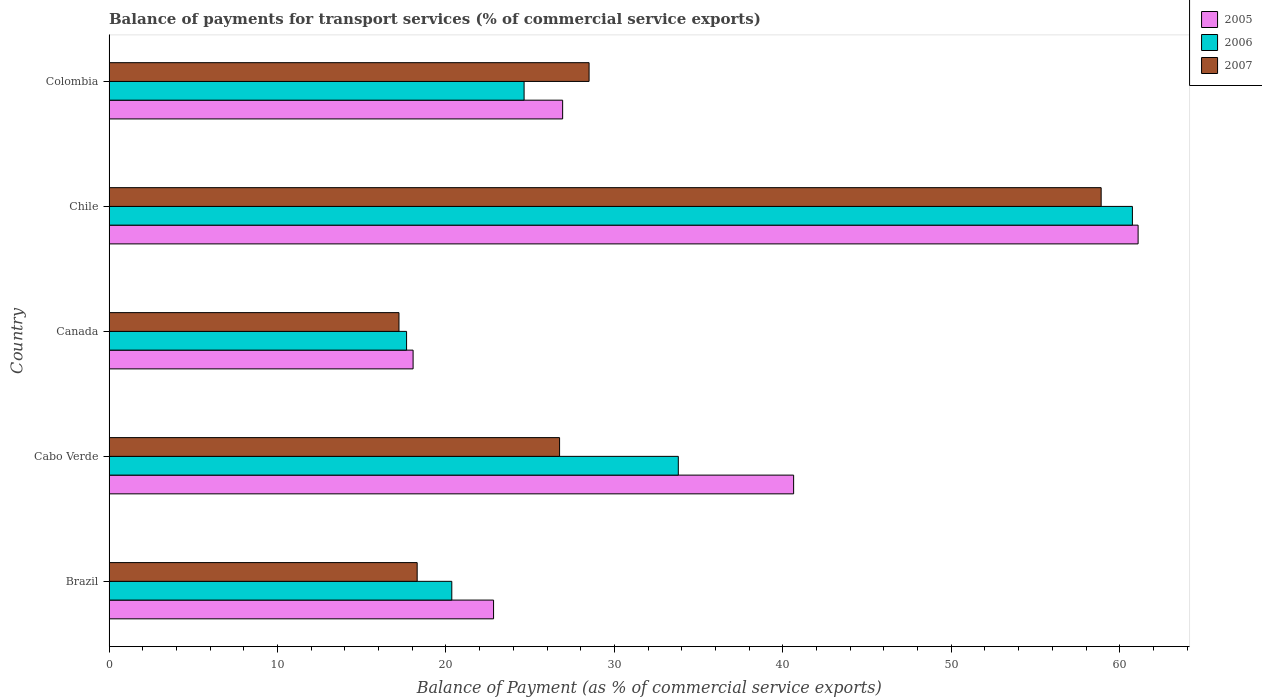How many different coloured bars are there?
Keep it short and to the point. 3. How many groups of bars are there?
Give a very brief answer. 5. Are the number of bars on each tick of the Y-axis equal?
Make the answer very short. Yes. How many bars are there on the 5th tick from the top?
Make the answer very short. 3. How many bars are there on the 1st tick from the bottom?
Offer a very short reply. 3. What is the label of the 3rd group of bars from the top?
Your answer should be very brief. Canada. In how many cases, is the number of bars for a given country not equal to the number of legend labels?
Offer a very short reply. 0. What is the balance of payments for transport services in 2005 in Canada?
Provide a short and direct response. 18.05. Across all countries, what is the maximum balance of payments for transport services in 2005?
Offer a very short reply. 61.09. Across all countries, what is the minimum balance of payments for transport services in 2006?
Your answer should be very brief. 17.66. In which country was the balance of payments for transport services in 2005 minimum?
Provide a short and direct response. Canada. What is the total balance of payments for transport services in 2007 in the graph?
Give a very brief answer. 149.64. What is the difference between the balance of payments for transport services in 2007 in Cabo Verde and that in Chile?
Offer a very short reply. -32.15. What is the difference between the balance of payments for transport services in 2007 in Brazil and the balance of payments for transport services in 2006 in Colombia?
Provide a short and direct response. -6.35. What is the average balance of payments for transport services in 2007 per country?
Ensure brevity in your answer.  29.93. What is the difference between the balance of payments for transport services in 2005 and balance of payments for transport services in 2006 in Colombia?
Your response must be concise. 2.29. What is the ratio of the balance of payments for transport services in 2006 in Chile to that in Colombia?
Your answer should be compact. 2.47. Is the balance of payments for transport services in 2005 in Canada less than that in Colombia?
Make the answer very short. Yes. Is the difference between the balance of payments for transport services in 2005 in Brazil and Chile greater than the difference between the balance of payments for transport services in 2006 in Brazil and Chile?
Your response must be concise. Yes. What is the difference between the highest and the second highest balance of payments for transport services in 2007?
Ensure brevity in your answer.  30.4. What is the difference between the highest and the lowest balance of payments for transport services in 2007?
Keep it short and to the point. 41.69. In how many countries, is the balance of payments for transport services in 2005 greater than the average balance of payments for transport services in 2005 taken over all countries?
Offer a terse response. 2. Is the sum of the balance of payments for transport services in 2005 in Canada and Colombia greater than the maximum balance of payments for transport services in 2007 across all countries?
Provide a short and direct response. No. What does the 3rd bar from the top in Colombia represents?
Ensure brevity in your answer.  2005. What does the 2nd bar from the bottom in Chile represents?
Ensure brevity in your answer.  2006. Is it the case that in every country, the sum of the balance of payments for transport services in 2006 and balance of payments for transport services in 2005 is greater than the balance of payments for transport services in 2007?
Provide a succinct answer. Yes. How many bars are there?
Provide a short and direct response. 15. Are all the bars in the graph horizontal?
Provide a short and direct response. Yes. How many countries are there in the graph?
Ensure brevity in your answer.  5. What is the difference between two consecutive major ticks on the X-axis?
Provide a short and direct response. 10. Are the values on the major ticks of X-axis written in scientific E-notation?
Offer a terse response. No. Does the graph contain any zero values?
Offer a very short reply. No. Does the graph contain grids?
Provide a succinct answer. No. Where does the legend appear in the graph?
Offer a terse response. Top right. How many legend labels are there?
Provide a short and direct response. 3. What is the title of the graph?
Your answer should be compact. Balance of payments for transport services (% of commercial service exports). Does "1960" appear as one of the legend labels in the graph?
Offer a terse response. No. What is the label or title of the X-axis?
Provide a short and direct response. Balance of Payment (as % of commercial service exports). What is the Balance of Payment (as % of commercial service exports) of 2005 in Brazil?
Your answer should be very brief. 22.83. What is the Balance of Payment (as % of commercial service exports) in 2006 in Brazil?
Give a very brief answer. 20.35. What is the Balance of Payment (as % of commercial service exports) in 2007 in Brazil?
Provide a short and direct response. 18.29. What is the Balance of Payment (as % of commercial service exports) of 2005 in Cabo Verde?
Offer a very short reply. 40.64. What is the Balance of Payment (as % of commercial service exports) in 2006 in Cabo Verde?
Offer a very short reply. 33.79. What is the Balance of Payment (as % of commercial service exports) in 2007 in Cabo Verde?
Make the answer very short. 26.75. What is the Balance of Payment (as % of commercial service exports) in 2005 in Canada?
Give a very brief answer. 18.05. What is the Balance of Payment (as % of commercial service exports) in 2006 in Canada?
Ensure brevity in your answer.  17.66. What is the Balance of Payment (as % of commercial service exports) in 2007 in Canada?
Make the answer very short. 17.21. What is the Balance of Payment (as % of commercial service exports) in 2005 in Chile?
Offer a terse response. 61.09. What is the Balance of Payment (as % of commercial service exports) in 2006 in Chile?
Provide a short and direct response. 60.75. What is the Balance of Payment (as % of commercial service exports) of 2007 in Chile?
Your response must be concise. 58.9. What is the Balance of Payment (as % of commercial service exports) in 2005 in Colombia?
Your response must be concise. 26.93. What is the Balance of Payment (as % of commercial service exports) in 2006 in Colombia?
Your answer should be compact. 24.64. What is the Balance of Payment (as % of commercial service exports) in 2007 in Colombia?
Your response must be concise. 28.5. Across all countries, what is the maximum Balance of Payment (as % of commercial service exports) in 2005?
Your answer should be very brief. 61.09. Across all countries, what is the maximum Balance of Payment (as % of commercial service exports) in 2006?
Make the answer very short. 60.75. Across all countries, what is the maximum Balance of Payment (as % of commercial service exports) of 2007?
Make the answer very short. 58.9. Across all countries, what is the minimum Balance of Payment (as % of commercial service exports) of 2005?
Give a very brief answer. 18.05. Across all countries, what is the minimum Balance of Payment (as % of commercial service exports) in 2006?
Provide a succinct answer. 17.66. Across all countries, what is the minimum Balance of Payment (as % of commercial service exports) of 2007?
Keep it short and to the point. 17.21. What is the total Balance of Payment (as % of commercial service exports) in 2005 in the graph?
Offer a very short reply. 169.53. What is the total Balance of Payment (as % of commercial service exports) of 2006 in the graph?
Ensure brevity in your answer.  157.2. What is the total Balance of Payment (as % of commercial service exports) in 2007 in the graph?
Provide a succinct answer. 149.64. What is the difference between the Balance of Payment (as % of commercial service exports) in 2005 in Brazil and that in Cabo Verde?
Ensure brevity in your answer.  -17.81. What is the difference between the Balance of Payment (as % of commercial service exports) in 2006 in Brazil and that in Cabo Verde?
Your response must be concise. -13.45. What is the difference between the Balance of Payment (as % of commercial service exports) of 2007 in Brazil and that in Cabo Verde?
Provide a short and direct response. -8.45. What is the difference between the Balance of Payment (as % of commercial service exports) of 2005 in Brazil and that in Canada?
Ensure brevity in your answer.  4.78. What is the difference between the Balance of Payment (as % of commercial service exports) in 2006 in Brazil and that in Canada?
Offer a terse response. 2.68. What is the difference between the Balance of Payment (as % of commercial service exports) of 2007 in Brazil and that in Canada?
Keep it short and to the point. 1.08. What is the difference between the Balance of Payment (as % of commercial service exports) of 2005 in Brazil and that in Chile?
Provide a succinct answer. -38.26. What is the difference between the Balance of Payment (as % of commercial service exports) in 2006 in Brazil and that in Chile?
Keep it short and to the point. -40.4. What is the difference between the Balance of Payment (as % of commercial service exports) in 2007 in Brazil and that in Chile?
Provide a succinct answer. -40.61. What is the difference between the Balance of Payment (as % of commercial service exports) in 2005 in Brazil and that in Colombia?
Your response must be concise. -4.1. What is the difference between the Balance of Payment (as % of commercial service exports) of 2006 in Brazil and that in Colombia?
Give a very brief answer. -4.29. What is the difference between the Balance of Payment (as % of commercial service exports) of 2007 in Brazil and that in Colombia?
Ensure brevity in your answer.  -10.21. What is the difference between the Balance of Payment (as % of commercial service exports) of 2005 in Cabo Verde and that in Canada?
Keep it short and to the point. 22.59. What is the difference between the Balance of Payment (as % of commercial service exports) in 2006 in Cabo Verde and that in Canada?
Offer a terse response. 16.13. What is the difference between the Balance of Payment (as % of commercial service exports) of 2007 in Cabo Verde and that in Canada?
Keep it short and to the point. 9.53. What is the difference between the Balance of Payment (as % of commercial service exports) in 2005 in Cabo Verde and that in Chile?
Ensure brevity in your answer.  -20.45. What is the difference between the Balance of Payment (as % of commercial service exports) of 2006 in Cabo Verde and that in Chile?
Your answer should be very brief. -26.96. What is the difference between the Balance of Payment (as % of commercial service exports) in 2007 in Cabo Verde and that in Chile?
Keep it short and to the point. -32.15. What is the difference between the Balance of Payment (as % of commercial service exports) of 2005 in Cabo Verde and that in Colombia?
Offer a terse response. 13.71. What is the difference between the Balance of Payment (as % of commercial service exports) in 2006 in Cabo Verde and that in Colombia?
Provide a succinct answer. 9.15. What is the difference between the Balance of Payment (as % of commercial service exports) of 2007 in Cabo Verde and that in Colombia?
Offer a terse response. -1.75. What is the difference between the Balance of Payment (as % of commercial service exports) in 2005 in Canada and that in Chile?
Ensure brevity in your answer.  -43.04. What is the difference between the Balance of Payment (as % of commercial service exports) in 2006 in Canada and that in Chile?
Provide a short and direct response. -43.09. What is the difference between the Balance of Payment (as % of commercial service exports) of 2007 in Canada and that in Chile?
Keep it short and to the point. -41.69. What is the difference between the Balance of Payment (as % of commercial service exports) in 2005 in Canada and that in Colombia?
Your response must be concise. -8.88. What is the difference between the Balance of Payment (as % of commercial service exports) of 2006 in Canada and that in Colombia?
Offer a terse response. -6.98. What is the difference between the Balance of Payment (as % of commercial service exports) of 2007 in Canada and that in Colombia?
Provide a succinct answer. -11.29. What is the difference between the Balance of Payment (as % of commercial service exports) of 2005 in Chile and that in Colombia?
Offer a very short reply. 34.16. What is the difference between the Balance of Payment (as % of commercial service exports) in 2006 in Chile and that in Colombia?
Your answer should be very brief. 36.11. What is the difference between the Balance of Payment (as % of commercial service exports) of 2007 in Chile and that in Colombia?
Your response must be concise. 30.4. What is the difference between the Balance of Payment (as % of commercial service exports) of 2005 in Brazil and the Balance of Payment (as % of commercial service exports) of 2006 in Cabo Verde?
Offer a very short reply. -10.97. What is the difference between the Balance of Payment (as % of commercial service exports) of 2005 in Brazil and the Balance of Payment (as % of commercial service exports) of 2007 in Cabo Verde?
Ensure brevity in your answer.  -3.92. What is the difference between the Balance of Payment (as % of commercial service exports) in 2006 in Brazil and the Balance of Payment (as % of commercial service exports) in 2007 in Cabo Verde?
Offer a terse response. -6.4. What is the difference between the Balance of Payment (as % of commercial service exports) in 2005 in Brazil and the Balance of Payment (as % of commercial service exports) in 2006 in Canada?
Your answer should be compact. 5.16. What is the difference between the Balance of Payment (as % of commercial service exports) in 2005 in Brazil and the Balance of Payment (as % of commercial service exports) in 2007 in Canada?
Your answer should be very brief. 5.62. What is the difference between the Balance of Payment (as % of commercial service exports) in 2006 in Brazil and the Balance of Payment (as % of commercial service exports) in 2007 in Canada?
Make the answer very short. 3.14. What is the difference between the Balance of Payment (as % of commercial service exports) of 2005 in Brazil and the Balance of Payment (as % of commercial service exports) of 2006 in Chile?
Give a very brief answer. -37.93. What is the difference between the Balance of Payment (as % of commercial service exports) in 2005 in Brazil and the Balance of Payment (as % of commercial service exports) in 2007 in Chile?
Make the answer very short. -36.07. What is the difference between the Balance of Payment (as % of commercial service exports) of 2006 in Brazil and the Balance of Payment (as % of commercial service exports) of 2007 in Chile?
Give a very brief answer. -38.55. What is the difference between the Balance of Payment (as % of commercial service exports) in 2005 in Brazil and the Balance of Payment (as % of commercial service exports) in 2006 in Colombia?
Your answer should be compact. -1.81. What is the difference between the Balance of Payment (as % of commercial service exports) of 2005 in Brazil and the Balance of Payment (as % of commercial service exports) of 2007 in Colombia?
Your answer should be compact. -5.67. What is the difference between the Balance of Payment (as % of commercial service exports) in 2006 in Brazil and the Balance of Payment (as % of commercial service exports) in 2007 in Colombia?
Your answer should be compact. -8.15. What is the difference between the Balance of Payment (as % of commercial service exports) in 2005 in Cabo Verde and the Balance of Payment (as % of commercial service exports) in 2006 in Canada?
Make the answer very short. 22.98. What is the difference between the Balance of Payment (as % of commercial service exports) of 2005 in Cabo Verde and the Balance of Payment (as % of commercial service exports) of 2007 in Canada?
Offer a terse response. 23.43. What is the difference between the Balance of Payment (as % of commercial service exports) of 2006 in Cabo Verde and the Balance of Payment (as % of commercial service exports) of 2007 in Canada?
Make the answer very short. 16.58. What is the difference between the Balance of Payment (as % of commercial service exports) of 2005 in Cabo Verde and the Balance of Payment (as % of commercial service exports) of 2006 in Chile?
Your answer should be compact. -20.11. What is the difference between the Balance of Payment (as % of commercial service exports) of 2005 in Cabo Verde and the Balance of Payment (as % of commercial service exports) of 2007 in Chile?
Keep it short and to the point. -18.26. What is the difference between the Balance of Payment (as % of commercial service exports) of 2006 in Cabo Verde and the Balance of Payment (as % of commercial service exports) of 2007 in Chile?
Your answer should be compact. -25.1. What is the difference between the Balance of Payment (as % of commercial service exports) in 2005 in Cabo Verde and the Balance of Payment (as % of commercial service exports) in 2006 in Colombia?
Keep it short and to the point. 16. What is the difference between the Balance of Payment (as % of commercial service exports) in 2005 in Cabo Verde and the Balance of Payment (as % of commercial service exports) in 2007 in Colombia?
Your response must be concise. 12.14. What is the difference between the Balance of Payment (as % of commercial service exports) in 2006 in Cabo Verde and the Balance of Payment (as % of commercial service exports) in 2007 in Colombia?
Keep it short and to the point. 5.3. What is the difference between the Balance of Payment (as % of commercial service exports) of 2005 in Canada and the Balance of Payment (as % of commercial service exports) of 2006 in Chile?
Offer a terse response. -42.7. What is the difference between the Balance of Payment (as % of commercial service exports) of 2005 in Canada and the Balance of Payment (as % of commercial service exports) of 2007 in Chile?
Keep it short and to the point. -40.85. What is the difference between the Balance of Payment (as % of commercial service exports) of 2006 in Canada and the Balance of Payment (as % of commercial service exports) of 2007 in Chile?
Offer a very short reply. -41.23. What is the difference between the Balance of Payment (as % of commercial service exports) in 2005 in Canada and the Balance of Payment (as % of commercial service exports) in 2006 in Colombia?
Your response must be concise. -6.59. What is the difference between the Balance of Payment (as % of commercial service exports) of 2005 in Canada and the Balance of Payment (as % of commercial service exports) of 2007 in Colombia?
Keep it short and to the point. -10.45. What is the difference between the Balance of Payment (as % of commercial service exports) of 2006 in Canada and the Balance of Payment (as % of commercial service exports) of 2007 in Colombia?
Your answer should be very brief. -10.83. What is the difference between the Balance of Payment (as % of commercial service exports) in 2005 in Chile and the Balance of Payment (as % of commercial service exports) in 2006 in Colombia?
Provide a succinct answer. 36.45. What is the difference between the Balance of Payment (as % of commercial service exports) in 2005 in Chile and the Balance of Payment (as % of commercial service exports) in 2007 in Colombia?
Offer a terse response. 32.59. What is the difference between the Balance of Payment (as % of commercial service exports) in 2006 in Chile and the Balance of Payment (as % of commercial service exports) in 2007 in Colombia?
Make the answer very short. 32.26. What is the average Balance of Payment (as % of commercial service exports) of 2005 per country?
Ensure brevity in your answer.  33.91. What is the average Balance of Payment (as % of commercial service exports) of 2006 per country?
Ensure brevity in your answer.  31.44. What is the average Balance of Payment (as % of commercial service exports) of 2007 per country?
Provide a short and direct response. 29.93. What is the difference between the Balance of Payment (as % of commercial service exports) in 2005 and Balance of Payment (as % of commercial service exports) in 2006 in Brazil?
Offer a very short reply. 2.48. What is the difference between the Balance of Payment (as % of commercial service exports) of 2005 and Balance of Payment (as % of commercial service exports) of 2007 in Brazil?
Your answer should be compact. 4.54. What is the difference between the Balance of Payment (as % of commercial service exports) in 2006 and Balance of Payment (as % of commercial service exports) in 2007 in Brazil?
Provide a short and direct response. 2.06. What is the difference between the Balance of Payment (as % of commercial service exports) in 2005 and Balance of Payment (as % of commercial service exports) in 2006 in Cabo Verde?
Make the answer very short. 6.85. What is the difference between the Balance of Payment (as % of commercial service exports) of 2005 and Balance of Payment (as % of commercial service exports) of 2007 in Cabo Verde?
Your response must be concise. 13.89. What is the difference between the Balance of Payment (as % of commercial service exports) in 2006 and Balance of Payment (as % of commercial service exports) in 2007 in Cabo Verde?
Your answer should be very brief. 7.05. What is the difference between the Balance of Payment (as % of commercial service exports) in 2005 and Balance of Payment (as % of commercial service exports) in 2006 in Canada?
Offer a terse response. 0.39. What is the difference between the Balance of Payment (as % of commercial service exports) of 2005 and Balance of Payment (as % of commercial service exports) of 2007 in Canada?
Your response must be concise. 0.84. What is the difference between the Balance of Payment (as % of commercial service exports) of 2006 and Balance of Payment (as % of commercial service exports) of 2007 in Canada?
Provide a succinct answer. 0.45. What is the difference between the Balance of Payment (as % of commercial service exports) in 2005 and Balance of Payment (as % of commercial service exports) in 2006 in Chile?
Offer a very short reply. 0.34. What is the difference between the Balance of Payment (as % of commercial service exports) in 2005 and Balance of Payment (as % of commercial service exports) in 2007 in Chile?
Make the answer very short. 2.19. What is the difference between the Balance of Payment (as % of commercial service exports) in 2006 and Balance of Payment (as % of commercial service exports) in 2007 in Chile?
Your response must be concise. 1.85. What is the difference between the Balance of Payment (as % of commercial service exports) in 2005 and Balance of Payment (as % of commercial service exports) in 2006 in Colombia?
Your answer should be compact. 2.29. What is the difference between the Balance of Payment (as % of commercial service exports) of 2005 and Balance of Payment (as % of commercial service exports) of 2007 in Colombia?
Keep it short and to the point. -1.57. What is the difference between the Balance of Payment (as % of commercial service exports) of 2006 and Balance of Payment (as % of commercial service exports) of 2007 in Colombia?
Offer a terse response. -3.86. What is the ratio of the Balance of Payment (as % of commercial service exports) in 2005 in Brazil to that in Cabo Verde?
Your answer should be compact. 0.56. What is the ratio of the Balance of Payment (as % of commercial service exports) in 2006 in Brazil to that in Cabo Verde?
Offer a terse response. 0.6. What is the ratio of the Balance of Payment (as % of commercial service exports) in 2007 in Brazil to that in Cabo Verde?
Keep it short and to the point. 0.68. What is the ratio of the Balance of Payment (as % of commercial service exports) in 2005 in Brazil to that in Canada?
Make the answer very short. 1.26. What is the ratio of the Balance of Payment (as % of commercial service exports) of 2006 in Brazil to that in Canada?
Offer a very short reply. 1.15. What is the ratio of the Balance of Payment (as % of commercial service exports) of 2007 in Brazil to that in Canada?
Offer a terse response. 1.06. What is the ratio of the Balance of Payment (as % of commercial service exports) of 2005 in Brazil to that in Chile?
Give a very brief answer. 0.37. What is the ratio of the Balance of Payment (as % of commercial service exports) in 2006 in Brazil to that in Chile?
Your answer should be very brief. 0.33. What is the ratio of the Balance of Payment (as % of commercial service exports) of 2007 in Brazil to that in Chile?
Offer a very short reply. 0.31. What is the ratio of the Balance of Payment (as % of commercial service exports) in 2005 in Brazil to that in Colombia?
Your answer should be very brief. 0.85. What is the ratio of the Balance of Payment (as % of commercial service exports) of 2006 in Brazil to that in Colombia?
Offer a very short reply. 0.83. What is the ratio of the Balance of Payment (as % of commercial service exports) of 2007 in Brazil to that in Colombia?
Your answer should be compact. 0.64. What is the ratio of the Balance of Payment (as % of commercial service exports) of 2005 in Cabo Verde to that in Canada?
Make the answer very short. 2.25. What is the ratio of the Balance of Payment (as % of commercial service exports) of 2006 in Cabo Verde to that in Canada?
Provide a short and direct response. 1.91. What is the ratio of the Balance of Payment (as % of commercial service exports) of 2007 in Cabo Verde to that in Canada?
Your answer should be very brief. 1.55. What is the ratio of the Balance of Payment (as % of commercial service exports) of 2005 in Cabo Verde to that in Chile?
Give a very brief answer. 0.67. What is the ratio of the Balance of Payment (as % of commercial service exports) in 2006 in Cabo Verde to that in Chile?
Offer a very short reply. 0.56. What is the ratio of the Balance of Payment (as % of commercial service exports) of 2007 in Cabo Verde to that in Chile?
Your response must be concise. 0.45. What is the ratio of the Balance of Payment (as % of commercial service exports) in 2005 in Cabo Verde to that in Colombia?
Make the answer very short. 1.51. What is the ratio of the Balance of Payment (as % of commercial service exports) in 2006 in Cabo Verde to that in Colombia?
Your response must be concise. 1.37. What is the ratio of the Balance of Payment (as % of commercial service exports) of 2007 in Cabo Verde to that in Colombia?
Your answer should be compact. 0.94. What is the ratio of the Balance of Payment (as % of commercial service exports) in 2005 in Canada to that in Chile?
Keep it short and to the point. 0.3. What is the ratio of the Balance of Payment (as % of commercial service exports) of 2006 in Canada to that in Chile?
Ensure brevity in your answer.  0.29. What is the ratio of the Balance of Payment (as % of commercial service exports) in 2007 in Canada to that in Chile?
Provide a succinct answer. 0.29. What is the ratio of the Balance of Payment (as % of commercial service exports) in 2005 in Canada to that in Colombia?
Offer a very short reply. 0.67. What is the ratio of the Balance of Payment (as % of commercial service exports) in 2006 in Canada to that in Colombia?
Make the answer very short. 0.72. What is the ratio of the Balance of Payment (as % of commercial service exports) in 2007 in Canada to that in Colombia?
Your answer should be very brief. 0.6. What is the ratio of the Balance of Payment (as % of commercial service exports) of 2005 in Chile to that in Colombia?
Provide a short and direct response. 2.27. What is the ratio of the Balance of Payment (as % of commercial service exports) in 2006 in Chile to that in Colombia?
Your response must be concise. 2.47. What is the ratio of the Balance of Payment (as % of commercial service exports) of 2007 in Chile to that in Colombia?
Make the answer very short. 2.07. What is the difference between the highest and the second highest Balance of Payment (as % of commercial service exports) in 2005?
Offer a very short reply. 20.45. What is the difference between the highest and the second highest Balance of Payment (as % of commercial service exports) of 2006?
Provide a succinct answer. 26.96. What is the difference between the highest and the second highest Balance of Payment (as % of commercial service exports) of 2007?
Your answer should be compact. 30.4. What is the difference between the highest and the lowest Balance of Payment (as % of commercial service exports) in 2005?
Ensure brevity in your answer.  43.04. What is the difference between the highest and the lowest Balance of Payment (as % of commercial service exports) of 2006?
Offer a very short reply. 43.09. What is the difference between the highest and the lowest Balance of Payment (as % of commercial service exports) of 2007?
Offer a terse response. 41.69. 